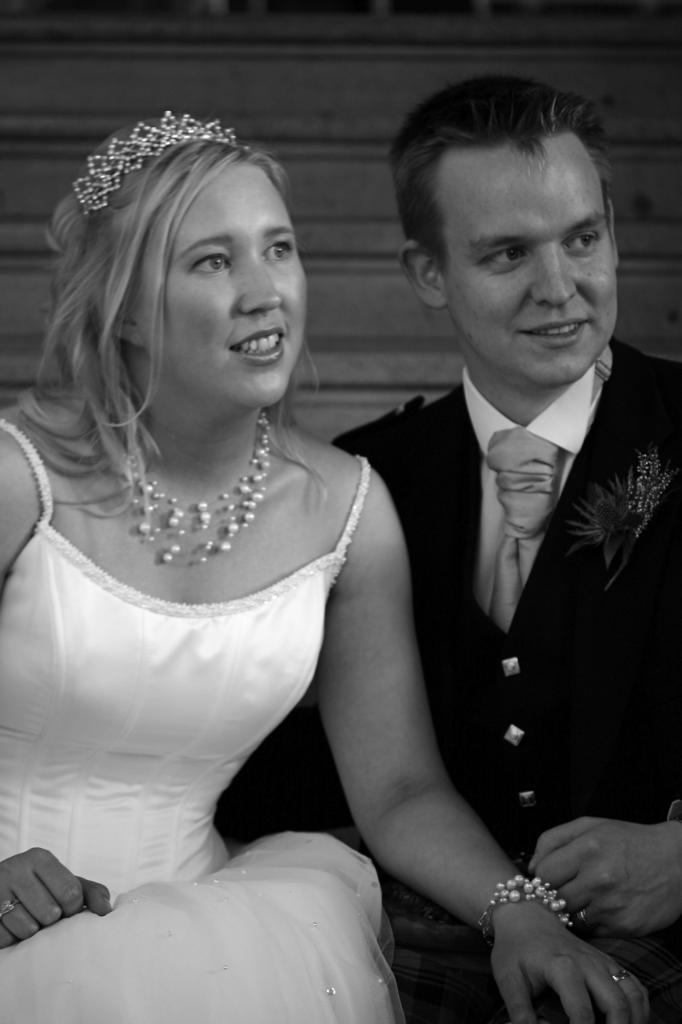Could you give a brief overview of what you see in this image? In this image there is a lady and a man. The lady is wearing white gown, crown. The man is wearing suit. In the background there are stairs. 